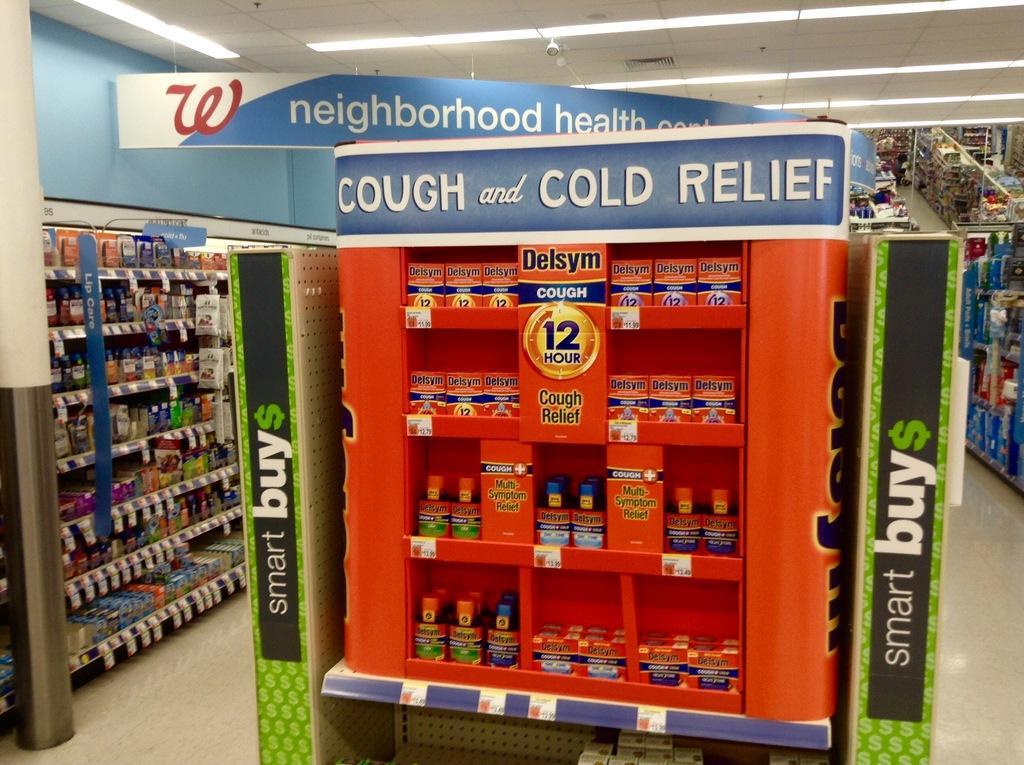How would you summarize this image in a sentence or two? In this image there are a few objects on the aisles with display boards in a supermarket. 